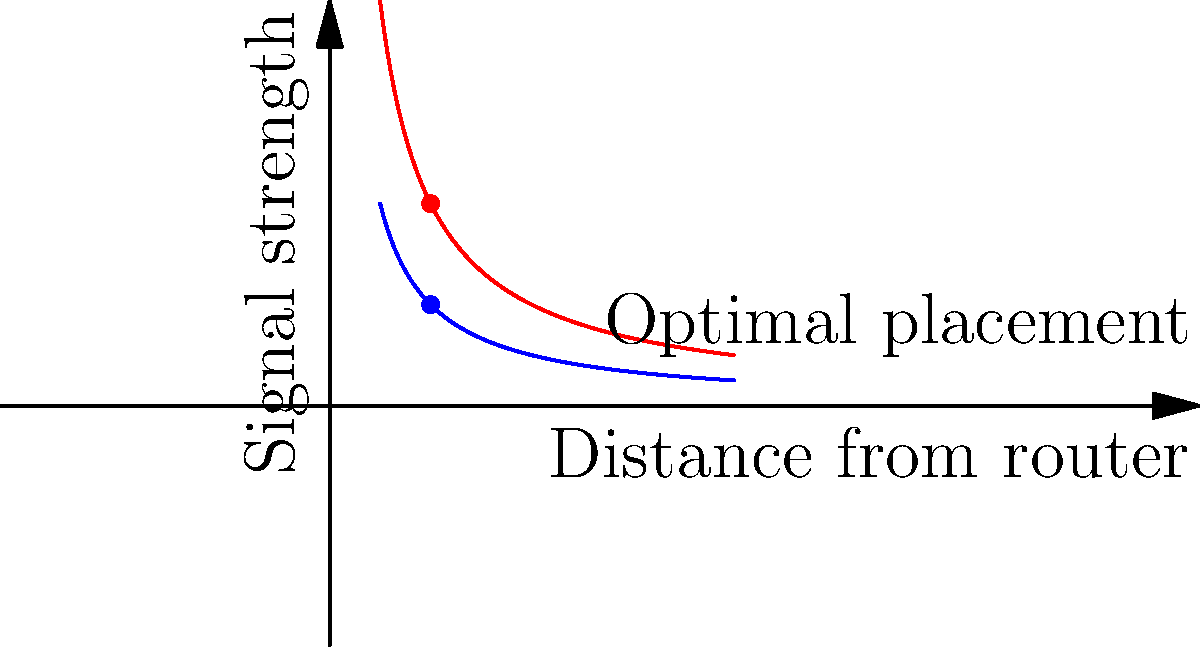How does the inverse square law, which describes the distribution of stars in the night sky, relate to optimal router placement in a large office space? 1. The inverse square law in astronomy states that the intensity of light from a star decreases proportionally to the square of the distance from the observer. This is represented by the equation:

   $$I \propto \frac{1}{r^2}$$

   where $I$ is the intensity and $r$ is the distance.

2. Similarly, in wireless networking, the signal strength of a router follows a similar principle:

   $$S \propto \frac{1}{d^2}$$

   where $S$ is the signal strength and $d$ is the distance from the router.

3. This relationship is illustrated in the graph, where the signal strength decreases rapidly as distance increases.

4. For optimal router placement:
   a) Place routers strategically to maximize coverage, similar to how stars are distributed across the sky.
   b) Consider overlapping coverage areas, like constellations in the night sky, to ensure consistent signal strength.
   c) Use multiple routers (as shown by the red and blue lines) to create a mesh network, analogous to star clusters providing brighter areas in the sky.

5. The optimal placement point is where the signal strengths intersect, providing balanced coverage from both routers.

6. This approach ensures that, like stars visible across the night sky, a strong Wi-Fi signal is available throughout the office space.
Answer: Place routers strategically with overlapping coverage areas, mimicking star distribution, to ensure consistent signal strength across the office space. 